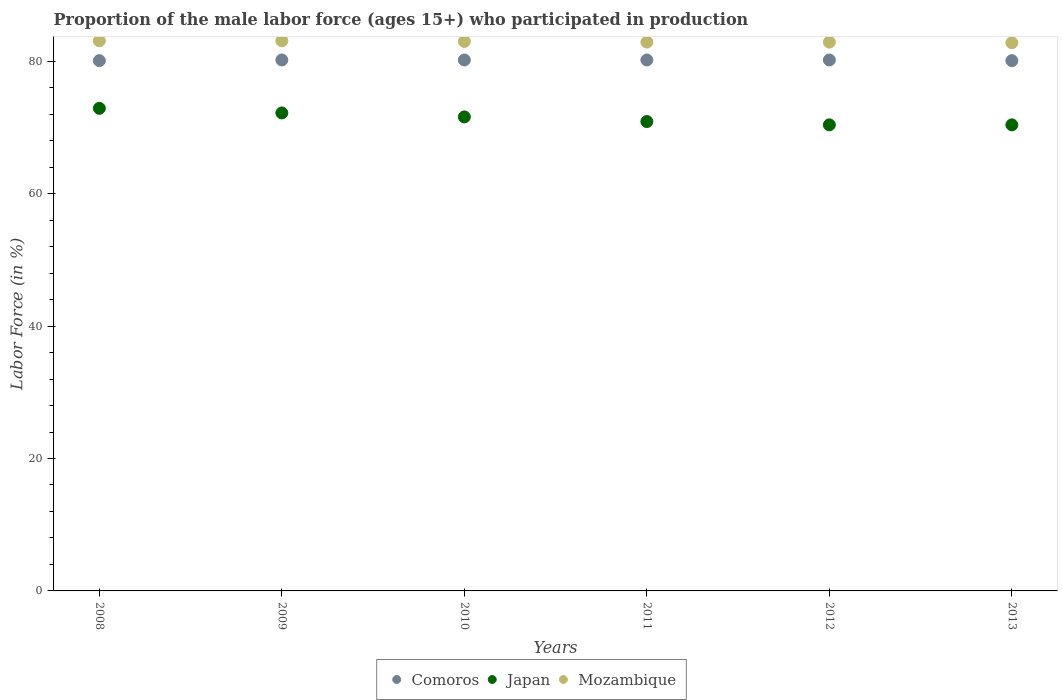What is the proportion of the male labor force who participated in production in Comoros in 2013?
Your answer should be compact. 80.1. Across all years, what is the maximum proportion of the male labor force who participated in production in Comoros?
Keep it short and to the point. 80.2. Across all years, what is the minimum proportion of the male labor force who participated in production in Mozambique?
Ensure brevity in your answer.  82.8. In which year was the proportion of the male labor force who participated in production in Comoros minimum?
Provide a succinct answer. 2008. What is the total proportion of the male labor force who participated in production in Comoros in the graph?
Keep it short and to the point. 481. What is the difference between the proportion of the male labor force who participated in production in Mozambique in 2008 and that in 2012?
Keep it short and to the point. 0.2. What is the difference between the proportion of the male labor force who participated in production in Comoros in 2008 and the proportion of the male labor force who participated in production in Japan in 2012?
Provide a short and direct response. 9.7. What is the average proportion of the male labor force who participated in production in Comoros per year?
Provide a succinct answer. 80.17. In the year 2013, what is the difference between the proportion of the male labor force who participated in production in Mozambique and proportion of the male labor force who participated in production in Comoros?
Give a very brief answer. 2.7. What is the ratio of the proportion of the male labor force who participated in production in Japan in 2009 to that in 2011?
Your response must be concise. 1.02. Is the difference between the proportion of the male labor force who participated in production in Mozambique in 2011 and 2012 greater than the difference between the proportion of the male labor force who participated in production in Comoros in 2011 and 2012?
Your answer should be compact. No. What is the difference between the highest and the second highest proportion of the male labor force who participated in production in Mozambique?
Keep it short and to the point. 0. What is the difference between the highest and the lowest proportion of the male labor force who participated in production in Japan?
Provide a short and direct response. 2.5. In how many years, is the proportion of the male labor force who participated in production in Mozambique greater than the average proportion of the male labor force who participated in production in Mozambique taken over all years?
Your answer should be compact. 3. Is the sum of the proportion of the male labor force who participated in production in Comoros in 2010 and 2013 greater than the maximum proportion of the male labor force who participated in production in Mozambique across all years?
Your response must be concise. Yes. How many years are there in the graph?
Your answer should be compact. 6. What is the difference between two consecutive major ticks on the Y-axis?
Your answer should be very brief. 20. Where does the legend appear in the graph?
Offer a very short reply. Bottom center. What is the title of the graph?
Provide a short and direct response. Proportion of the male labor force (ages 15+) who participated in production. Does "Latvia" appear as one of the legend labels in the graph?
Your answer should be compact. No. What is the label or title of the Y-axis?
Make the answer very short. Labor Force (in %). What is the Labor Force (in %) in Comoros in 2008?
Ensure brevity in your answer.  80.1. What is the Labor Force (in %) of Japan in 2008?
Keep it short and to the point. 72.9. What is the Labor Force (in %) of Mozambique in 2008?
Offer a terse response. 83.1. What is the Labor Force (in %) in Comoros in 2009?
Keep it short and to the point. 80.2. What is the Labor Force (in %) in Japan in 2009?
Ensure brevity in your answer.  72.2. What is the Labor Force (in %) in Mozambique in 2009?
Your response must be concise. 83.1. What is the Labor Force (in %) of Comoros in 2010?
Offer a very short reply. 80.2. What is the Labor Force (in %) of Japan in 2010?
Your response must be concise. 71.6. What is the Labor Force (in %) in Comoros in 2011?
Your answer should be very brief. 80.2. What is the Labor Force (in %) of Japan in 2011?
Your answer should be very brief. 70.9. What is the Labor Force (in %) in Mozambique in 2011?
Ensure brevity in your answer.  82.9. What is the Labor Force (in %) in Comoros in 2012?
Your response must be concise. 80.2. What is the Labor Force (in %) of Japan in 2012?
Offer a terse response. 70.4. What is the Labor Force (in %) of Mozambique in 2012?
Offer a terse response. 82.9. What is the Labor Force (in %) of Comoros in 2013?
Provide a succinct answer. 80.1. What is the Labor Force (in %) of Japan in 2013?
Ensure brevity in your answer.  70.4. What is the Labor Force (in %) of Mozambique in 2013?
Offer a very short reply. 82.8. Across all years, what is the maximum Labor Force (in %) in Comoros?
Provide a short and direct response. 80.2. Across all years, what is the maximum Labor Force (in %) in Japan?
Provide a short and direct response. 72.9. Across all years, what is the maximum Labor Force (in %) of Mozambique?
Offer a terse response. 83.1. Across all years, what is the minimum Labor Force (in %) in Comoros?
Offer a terse response. 80.1. Across all years, what is the minimum Labor Force (in %) in Japan?
Offer a very short reply. 70.4. Across all years, what is the minimum Labor Force (in %) of Mozambique?
Your response must be concise. 82.8. What is the total Labor Force (in %) of Comoros in the graph?
Provide a succinct answer. 481. What is the total Labor Force (in %) in Japan in the graph?
Give a very brief answer. 428.4. What is the total Labor Force (in %) of Mozambique in the graph?
Keep it short and to the point. 497.8. What is the difference between the Labor Force (in %) in Japan in 2008 and that in 2009?
Offer a terse response. 0.7. What is the difference between the Labor Force (in %) of Comoros in 2008 and that in 2010?
Your answer should be very brief. -0.1. What is the difference between the Labor Force (in %) of Mozambique in 2008 and that in 2010?
Give a very brief answer. 0.1. What is the difference between the Labor Force (in %) of Japan in 2008 and that in 2011?
Keep it short and to the point. 2. What is the difference between the Labor Force (in %) in Japan in 2008 and that in 2012?
Your response must be concise. 2.5. What is the difference between the Labor Force (in %) of Japan in 2008 and that in 2013?
Make the answer very short. 2.5. What is the difference between the Labor Force (in %) in Mozambique in 2008 and that in 2013?
Give a very brief answer. 0.3. What is the difference between the Labor Force (in %) in Comoros in 2009 and that in 2010?
Ensure brevity in your answer.  0. What is the difference between the Labor Force (in %) of Mozambique in 2009 and that in 2010?
Provide a succinct answer. 0.1. What is the difference between the Labor Force (in %) of Comoros in 2009 and that in 2012?
Make the answer very short. 0. What is the difference between the Labor Force (in %) in Mozambique in 2009 and that in 2012?
Your response must be concise. 0.2. What is the difference between the Labor Force (in %) of Comoros in 2009 and that in 2013?
Keep it short and to the point. 0.1. What is the difference between the Labor Force (in %) of Mozambique in 2009 and that in 2013?
Offer a terse response. 0.3. What is the difference between the Labor Force (in %) of Japan in 2010 and that in 2011?
Offer a very short reply. 0.7. What is the difference between the Labor Force (in %) of Mozambique in 2010 and that in 2011?
Keep it short and to the point. 0.1. What is the difference between the Labor Force (in %) in Comoros in 2010 and that in 2012?
Make the answer very short. 0. What is the difference between the Labor Force (in %) in Comoros in 2010 and that in 2013?
Keep it short and to the point. 0.1. What is the difference between the Labor Force (in %) in Japan in 2010 and that in 2013?
Provide a succinct answer. 1.2. What is the difference between the Labor Force (in %) of Comoros in 2011 and that in 2012?
Keep it short and to the point. 0. What is the difference between the Labor Force (in %) in Japan in 2011 and that in 2012?
Provide a succinct answer. 0.5. What is the difference between the Labor Force (in %) in Mozambique in 2011 and that in 2012?
Make the answer very short. 0. What is the difference between the Labor Force (in %) in Comoros in 2011 and that in 2013?
Keep it short and to the point. 0.1. What is the difference between the Labor Force (in %) of Mozambique in 2011 and that in 2013?
Provide a short and direct response. 0.1. What is the difference between the Labor Force (in %) of Japan in 2012 and that in 2013?
Provide a succinct answer. 0. What is the difference between the Labor Force (in %) of Mozambique in 2012 and that in 2013?
Your answer should be very brief. 0.1. What is the difference between the Labor Force (in %) of Comoros in 2008 and the Labor Force (in %) of Japan in 2009?
Ensure brevity in your answer.  7.9. What is the difference between the Labor Force (in %) of Comoros in 2008 and the Labor Force (in %) of Mozambique in 2009?
Give a very brief answer. -3. What is the difference between the Labor Force (in %) of Comoros in 2008 and the Labor Force (in %) of Japan in 2010?
Your response must be concise. 8.5. What is the difference between the Labor Force (in %) in Comoros in 2008 and the Labor Force (in %) in Mozambique in 2010?
Your answer should be very brief. -2.9. What is the difference between the Labor Force (in %) of Comoros in 2008 and the Labor Force (in %) of Japan in 2011?
Provide a short and direct response. 9.2. What is the difference between the Labor Force (in %) of Japan in 2008 and the Labor Force (in %) of Mozambique in 2011?
Keep it short and to the point. -10. What is the difference between the Labor Force (in %) in Comoros in 2008 and the Labor Force (in %) in Japan in 2012?
Offer a terse response. 9.7. What is the difference between the Labor Force (in %) of Comoros in 2008 and the Labor Force (in %) of Mozambique in 2012?
Your answer should be compact. -2.8. What is the difference between the Labor Force (in %) in Comoros in 2008 and the Labor Force (in %) in Japan in 2013?
Ensure brevity in your answer.  9.7. What is the difference between the Labor Force (in %) in Japan in 2008 and the Labor Force (in %) in Mozambique in 2013?
Ensure brevity in your answer.  -9.9. What is the difference between the Labor Force (in %) of Comoros in 2009 and the Labor Force (in %) of Mozambique in 2010?
Keep it short and to the point. -2.8. What is the difference between the Labor Force (in %) of Japan in 2009 and the Labor Force (in %) of Mozambique in 2010?
Give a very brief answer. -10.8. What is the difference between the Labor Force (in %) in Comoros in 2009 and the Labor Force (in %) in Japan in 2011?
Keep it short and to the point. 9.3. What is the difference between the Labor Force (in %) in Comoros in 2009 and the Labor Force (in %) in Mozambique in 2011?
Ensure brevity in your answer.  -2.7. What is the difference between the Labor Force (in %) in Comoros in 2009 and the Labor Force (in %) in Japan in 2012?
Make the answer very short. 9.8. What is the difference between the Labor Force (in %) of Comoros in 2009 and the Labor Force (in %) of Mozambique in 2012?
Make the answer very short. -2.7. What is the difference between the Labor Force (in %) of Japan in 2009 and the Labor Force (in %) of Mozambique in 2012?
Your answer should be compact. -10.7. What is the difference between the Labor Force (in %) in Comoros in 2009 and the Labor Force (in %) in Japan in 2013?
Keep it short and to the point. 9.8. What is the difference between the Labor Force (in %) in Comoros in 2009 and the Labor Force (in %) in Mozambique in 2013?
Offer a very short reply. -2.6. What is the difference between the Labor Force (in %) in Comoros in 2010 and the Labor Force (in %) in Japan in 2011?
Your answer should be compact. 9.3. What is the difference between the Labor Force (in %) of Comoros in 2010 and the Labor Force (in %) of Mozambique in 2011?
Make the answer very short. -2.7. What is the difference between the Labor Force (in %) in Japan in 2010 and the Labor Force (in %) in Mozambique in 2011?
Give a very brief answer. -11.3. What is the difference between the Labor Force (in %) of Comoros in 2010 and the Labor Force (in %) of Mozambique in 2012?
Provide a succinct answer. -2.7. What is the difference between the Labor Force (in %) in Comoros in 2010 and the Labor Force (in %) in Japan in 2013?
Ensure brevity in your answer.  9.8. What is the difference between the Labor Force (in %) of Comoros in 2010 and the Labor Force (in %) of Mozambique in 2013?
Your answer should be compact. -2.6. What is the difference between the Labor Force (in %) of Japan in 2010 and the Labor Force (in %) of Mozambique in 2013?
Offer a very short reply. -11.2. What is the difference between the Labor Force (in %) of Comoros in 2011 and the Labor Force (in %) of Japan in 2012?
Make the answer very short. 9.8. What is the difference between the Labor Force (in %) of Comoros in 2011 and the Labor Force (in %) of Mozambique in 2012?
Offer a very short reply. -2.7. What is the difference between the Labor Force (in %) in Japan in 2011 and the Labor Force (in %) in Mozambique in 2012?
Keep it short and to the point. -12. What is the difference between the Labor Force (in %) in Comoros in 2011 and the Labor Force (in %) in Japan in 2013?
Provide a short and direct response. 9.8. What is the difference between the Labor Force (in %) in Japan in 2011 and the Labor Force (in %) in Mozambique in 2013?
Ensure brevity in your answer.  -11.9. What is the difference between the Labor Force (in %) in Comoros in 2012 and the Labor Force (in %) in Japan in 2013?
Ensure brevity in your answer.  9.8. What is the difference between the Labor Force (in %) of Comoros in 2012 and the Labor Force (in %) of Mozambique in 2013?
Your answer should be very brief. -2.6. What is the average Labor Force (in %) of Comoros per year?
Offer a very short reply. 80.17. What is the average Labor Force (in %) in Japan per year?
Provide a short and direct response. 71.4. What is the average Labor Force (in %) of Mozambique per year?
Offer a terse response. 82.97. In the year 2009, what is the difference between the Labor Force (in %) in Japan and Labor Force (in %) in Mozambique?
Give a very brief answer. -10.9. In the year 2010, what is the difference between the Labor Force (in %) of Comoros and Labor Force (in %) of Mozambique?
Your answer should be compact. -2.8. In the year 2011, what is the difference between the Labor Force (in %) of Japan and Labor Force (in %) of Mozambique?
Offer a very short reply. -12. In the year 2012, what is the difference between the Labor Force (in %) of Comoros and Labor Force (in %) of Mozambique?
Provide a short and direct response. -2.7. What is the ratio of the Labor Force (in %) in Comoros in 2008 to that in 2009?
Ensure brevity in your answer.  1. What is the ratio of the Labor Force (in %) of Japan in 2008 to that in 2009?
Your answer should be very brief. 1.01. What is the ratio of the Labor Force (in %) of Mozambique in 2008 to that in 2009?
Provide a short and direct response. 1. What is the ratio of the Labor Force (in %) of Japan in 2008 to that in 2010?
Give a very brief answer. 1.02. What is the ratio of the Labor Force (in %) in Japan in 2008 to that in 2011?
Offer a very short reply. 1.03. What is the ratio of the Labor Force (in %) of Mozambique in 2008 to that in 2011?
Ensure brevity in your answer.  1. What is the ratio of the Labor Force (in %) in Comoros in 2008 to that in 2012?
Offer a very short reply. 1. What is the ratio of the Labor Force (in %) in Japan in 2008 to that in 2012?
Give a very brief answer. 1.04. What is the ratio of the Labor Force (in %) in Mozambique in 2008 to that in 2012?
Provide a succinct answer. 1. What is the ratio of the Labor Force (in %) of Comoros in 2008 to that in 2013?
Your answer should be very brief. 1. What is the ratio of the Labor Force (in %) of Japan in 2008 to that in 2013?
Your answer should be very brief. 1.04. What is the ratio of the Labor Force (in %) in Comoros in 2009 to that in 2010?
Offer a terse response. 1. What is the ratio of the Labor Force (in %) in Japan in 2009 to that in 2010?
Provide a succinct answer. 1.01. What is the ratio of the Labor Force (in %) in Mozambique in 2009 to that in 2010?
Ensure brevity in your answer.  1. What is the ratio of the Labor Force (in %) in Japan in 2009 to that in 2011?
Provide a short and direct response. 1.02. What is the ratio of the Labor Force (in %) of Japan in 2009 to that in 2012?
Offer a very short reply. 1.03. What is the ratio of the Labor Force (in %) in Comoros in 2009 to that in 2013?
Your response must be concise. 1. What is the ratio of the Labor Force (in %) of Japan in 2009 to that in 2013?
Provide a short and direct response. 1.03. What is the ratio of the Labor Force (in %) in Comoros in 2010 to that in 2011?
Give a very brief answer. 1. What is the ratio of the Labor Force (in %) of Japan in 2010 to that in 2011?
Make the answer very short. 1.01. What is the ratio of the Labor Force (in %) of Comoros in 2010 to that in 2012?
Provide a succinct answer. 1. What is the ratio of the Labor Force (in %) in Japan in 2010 to that in 2012?
Keep it short and to the point. 1.02. What is the ratio of the Labor Force (in %) in Mozambique in 2010 to that in 2012?
Ensure brevity in your answer.  1. What is the ratio of the Labor Force (in %) of Comoros in 2010 to that in 2013?
Your response must be concise. 1. What is the ratio of the Labor Force (in %) in Japan in 2010 to that in 2013?
Provide a succinct answer. 1.02. What is the ratio of the Labor Force (in %) of Mozambique in 2010 to that in 2013?
Make the answer very short. 1. What is the ratio of the Labor Force (in %) in Comoros in 2011 to that in 2012?
Offer a very short reply. 1. What is the ratio of the Labor Force (in %) of Japan in 2011 to that in 2012?
Give a very brief answer. 1.01. What is the ratio of the Labor Force (in %) of Mozambique in 2011 to that in 2012?
Offer a terse response. 1. What is the ratio of the Labor Force (in %) of Japan in 2011 to that in 2013?
Keep it short and to the point. 1.01. What is the difference between the highest and the second highest Labor Force (in %) in Comoros?
Your answer should be very brief. 0. What is the difference between the highest and the second highest Labor Force (in %) of Mozambique?
Keep it short and to the point. 0. What is the difference between the highest and the lowest Labor Force (in %) of Japan?
Your response must be concise. 2.5. 